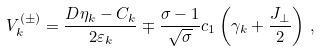<formula> <loc_0><loc_0><loc_500><loc_500>V _ { k } ^ { ( \pm ) } = \frac { D \eta _ { k } - C _ { k } } { 2 \varepsilon _ { k } } \mp \frac { \sigma - 1 } { \sqrt { \sigma } } c _ { 1 } \left ( \gamma _ { k } + \frac { J _ { \perp } } { 2 } \right ) \, ,</formula> 